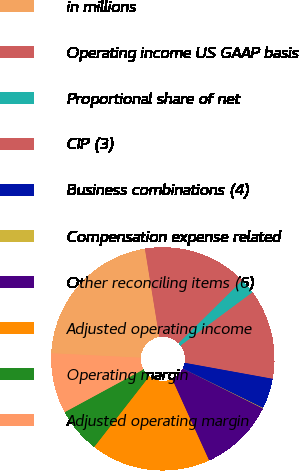Convert chart to OTSL. <chart><loc_0><loc_0><loc_500><loc_500><pie_chart><fcel>in millions<fcel>Operating income US GAAP basis<fcel>Proportional share of net<fcel>CIP (3)<fcel>Business combinations (4)<fcel>Compensation expense related<fcel>Other reconciling items (6)<fcel>Adjusted operating income<fcel>Operating margin<fcel>Adjusted operating margin<nl><fcel>21.64%<fcel>15.17%<fcel>2.24%<fcel>13.02%<fcel>4.4%<fcel>0.09%<fcel>10.86%<fcel>17.33%<fcel>6.55%<fcel>8.71%<nl></chart> 